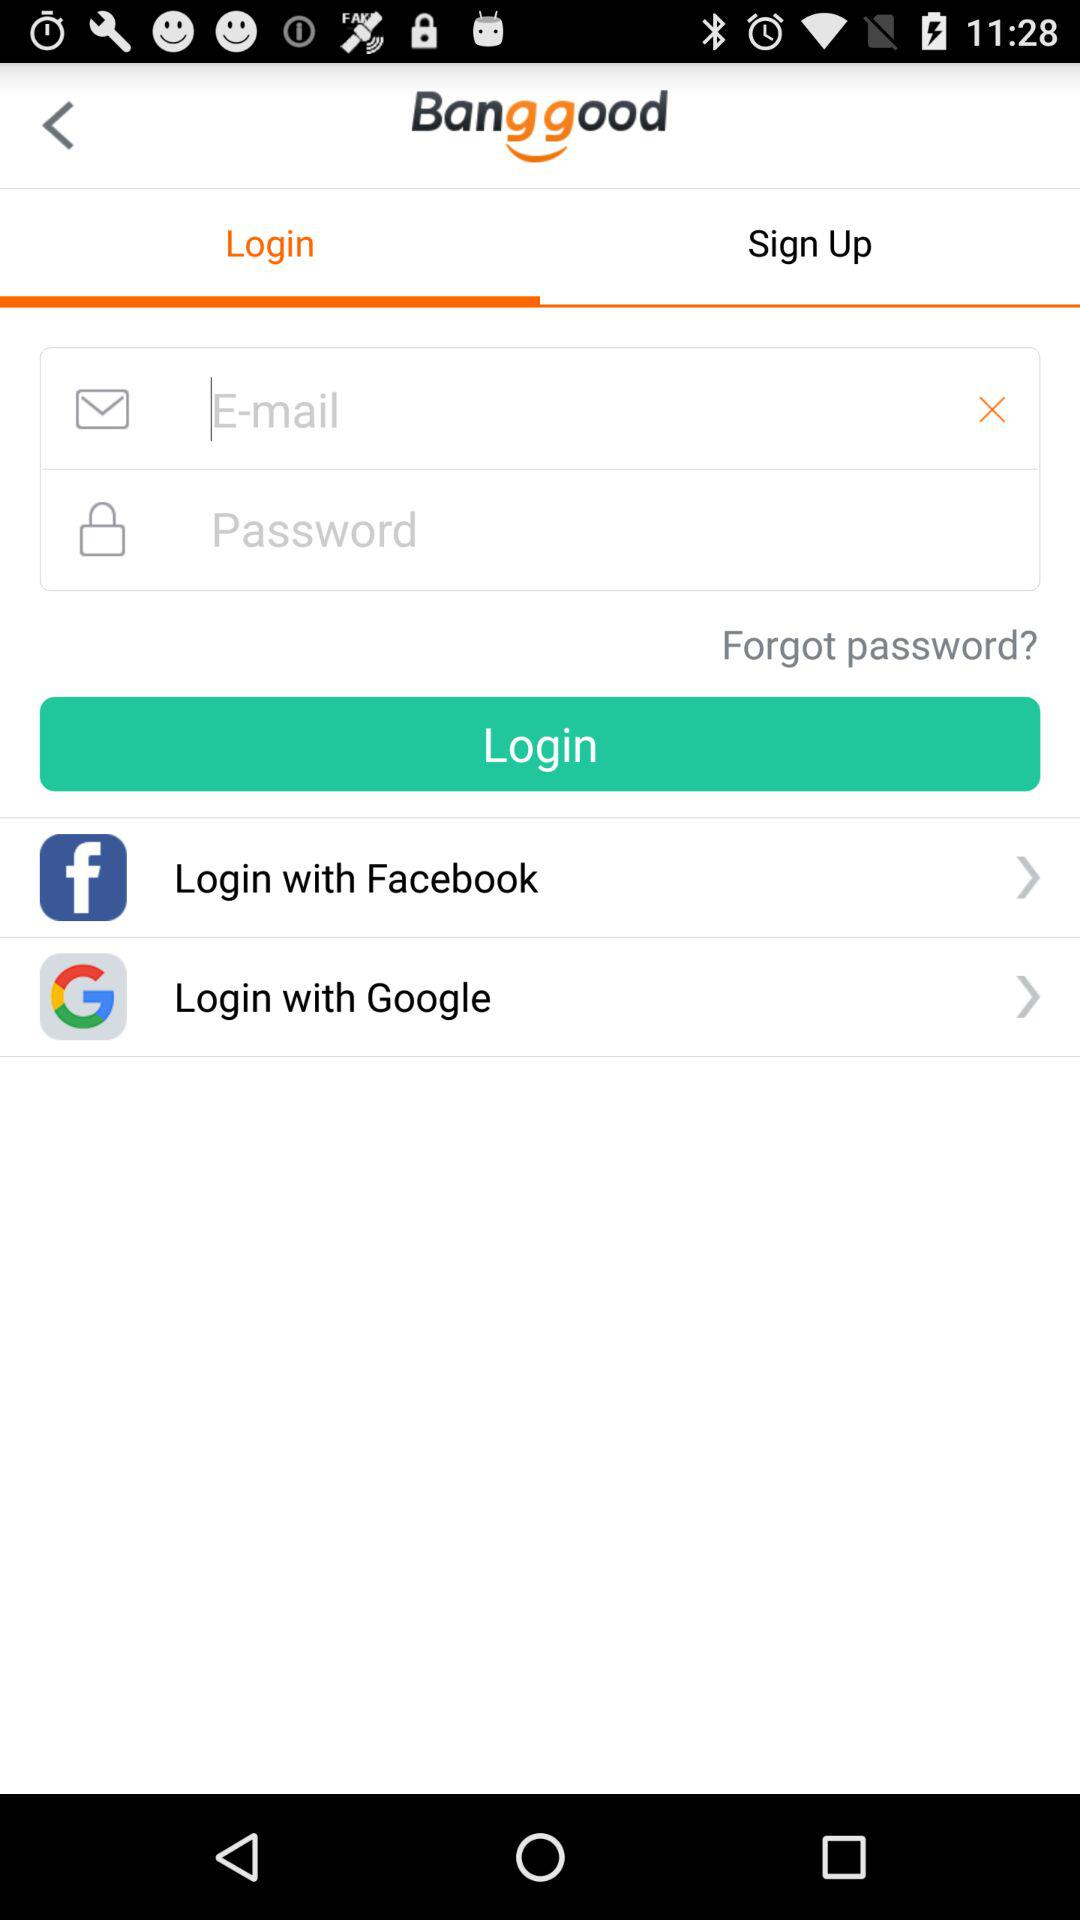Which account I can use for login? You can use an "E-mail", "Facebook" and "Google" account. 